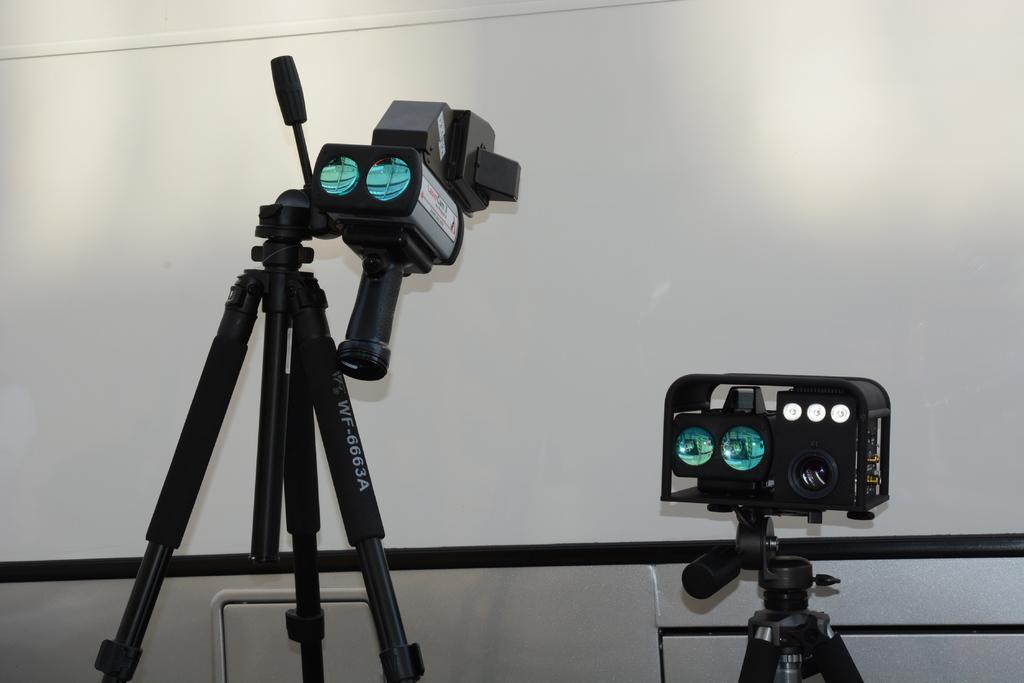Could you give a brief overview of what you see in this image? In the image there are two gadgets in the foreground. 